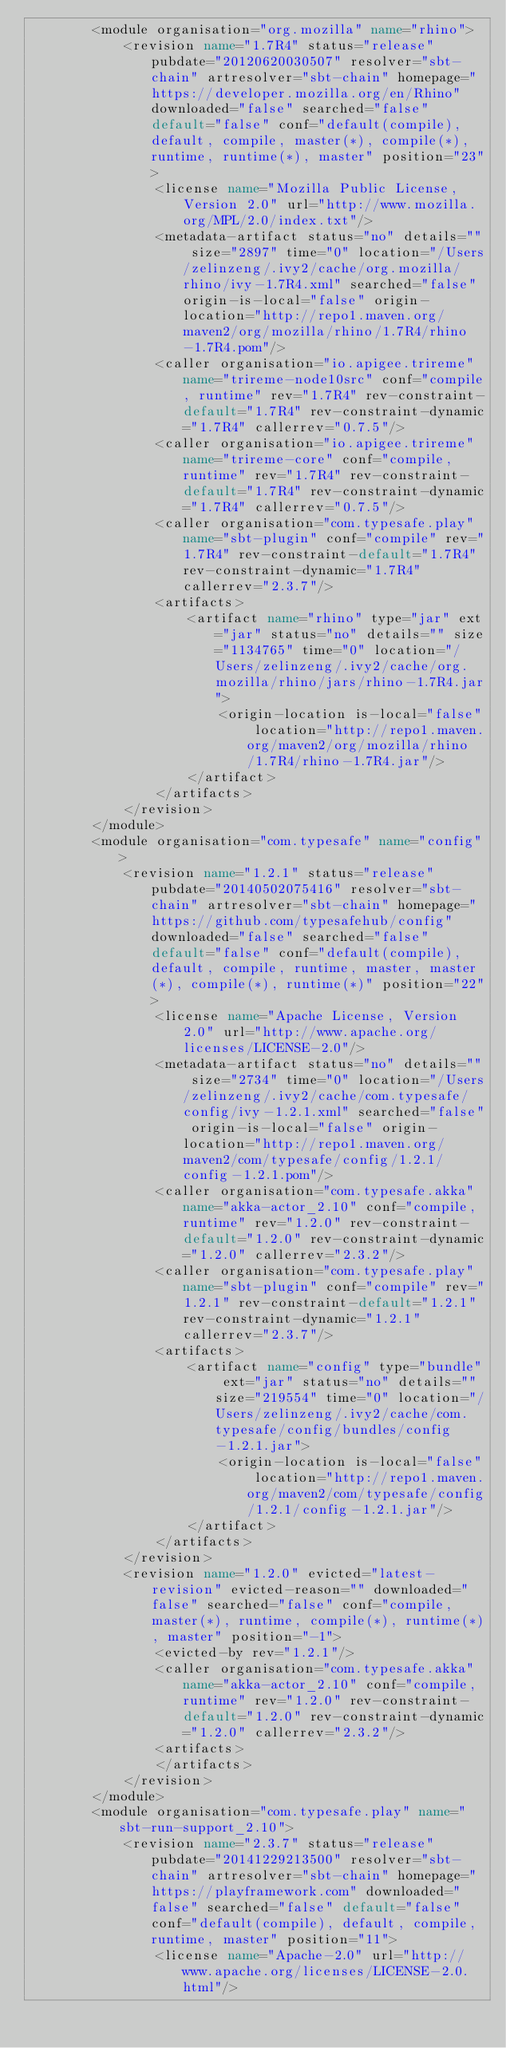<code> <loc_0><loc_0><loc_500><loc_500><_XML_>		<module organisation="org.mozilla" name="rhino">
			<revision name="1.7R4" status="release" pubdate="20120620030507" resolver="sbt-chain" artresolver="sbt-chain" homepage="https://developer.mozilla.org/en/Rhino" downloaded="false" searched="false" default="false" conf="default(compile), default, compile, master(*), compile(*), runtime, runtime(*), master" position="23">
				<license name="Mozilla Public License, Version 2.0" url="http://www.mozilla.org/MPL/2.0/index.txt"/>
				<metadata-artifact status="no" details="" size="2897" time="0" location="/Users/zelinzeng/.ivy2/cache/org.mozilla/rhino/ivy-1.7R4.xml" searched="false" origin-is-local="false" origin-location="http://repo1.maven.org/maven2/org/mozilla/rhino/1.7R4/rhino-1.7R4.pom"/>
				<caller organisation="io.apigee.trireme" name="trireme-node10src" conf="compile, runtime" rev="1.7R4" rev-constraint-default="1.7R4" rev-constraint-dynamic="1.7R4" callerrev="0.7.5"/>
				<caller organisation="io.apigee.trireme" name="trireme-core" conf="compile, runtime" rev="1.7R4" rev-constraint-default="1.7R4" rev-constraint-dynamic="1.7R4" callerrev="0.7.5"/>
				<caller organisation="com.typesafe.play" name="sbt-plugin" conf="compile" rev="1.7R4" rev-constraint-default="1.7R4" rev-constraint-dynamic="1.7R4" callerrev="2.3.7"/>
				<artifacts>
					<artifact name="rhino" type="jar" ext="jar" status="no" details="" size="1134765" time="0" location="/Users/zelinzeng/.ivy2/cache/org.mozilla/rhino/jars/rhino-1.7R4.jar">
						<origin-location is-local="false" location="http://repo1.maven.org/maven2/org/mozilla/rhino/1.7R4/rhino-1.7R4.jar"/>
					</artifact>
				</artifacts>
			</revision>
		</module>
		<module organisation="com.typesafe" name="config">
			<revision name="1.2.1" status="release" pubdate="20140502075416" resolver="sbt-chain" artresolver="sbt-chain" homepage="https://github.com/typesafehub/config" downloaded="false" searched="false" default="false" conf="default(compile), default, compile, runtime, master, master(*), compile(*), runtime(*)" position="22">
				<license name="Apache License, Version 2.0" url="http://www.apache.org/licenses/LICENSE-2.0"/>
				<metadata-artifact status="no" details="" size="2734" time="0" location="/Users/zelinzeng/.ivy2/cache/com.typesafe/config/ivy-1.2.1.xml" searched="false" origin-is-local="false" origin-location="http://repo1.maven.org/maven2/com/typesafe/config/1.2.1/config-1.2.1.pom"/>
				<caller organisation="com.typesafe.akka" name="akka-actor_2.10" conf="compile, runtime" rev="1.2.0" rev-constraint-default="1.2.0" rev-constraint-dynamic="1.2.0" callerrev="2.3.2"/>
				<caller organisation="com.typesafe.play" name="sbt-plugin" conf="compile" rev="1.2.1" rev-constraint-default="1.2.1" rev-constraint-dynamic="1.2.1" callerrev="2.3.7"/>
				<artifacts>
					<artifact name="config" type="bundle" ext="jar" status="no" details="" size="219554" time="0" location="/Users/zelinzeng/.ivy2/cache/com.typesafe/config/bundles/config-1.2.1.jar">
						<origin-location is-local="false" location="http://repo1.maven.org/maven2/com/typesafe/config/1.2.1/config-1.2.1.jar"/>
					</artifact>
				</artifacts>
			</revision>
			<revision name="1.2.0" evicted="latest-revision" evicted-reason="" downloaded="false" searched="false" conf="compile, master(*), runtime, compile(*), runtime(*), master" position="-1">
				<evicted-by rev="1.2.1"/>
				<caller organisation="com.typesafe.akka" name="akka-actor_2.10" conf="compile, runtime" rev="1.2.0" rev-constraint-default="1.2.0" rev-constraint-dynamic="1.2.0" callerrev="2.3.2"/>
				<artifacts>
				</artifacts>
			</revision>
		</module>
		<module organisation="com.typesafe.play" name="sbt-run-support_2.10">
			<revision name="2.3.7" status="release" pubdate="20141229213500" resolver="sbt-chain" artresolver="sbt-chain" homepage="https://playframework.com" downloaded="false" searched="false" default="false" conf="default(compile), default, compile, runtime, master" position="11">
				<license name="Apache-2.0" url="http://www.apache.org/licenses/LICENSE-2.0.html"/></code> 